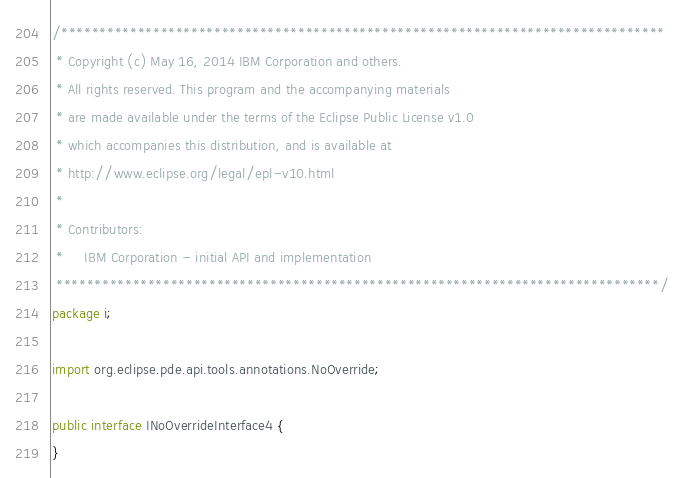Convert code to text. <code><loc_0><loc_0><loc_500><loc_500><_Java_>/*******************************************************************************
 * Copyright (c) May 16, 2014 IBM Corporation and others.
 * All rights reserved. This program and the accompanying materials
 * are made available under the terms of the Eclipse Public License v1.0
 * which accompanies this distribution, and is available at
 * http://www.eclipse.org/legal/epl-v10.html
 *
 * Contributors:
 *     IBM Corporation - initial API and implementation
 *******************************************************************************/
package i;

import org.eclipse.pde.api.tools.annotations.NoOverride;

public interface INoOverrideInterface4 {
}
</code> 